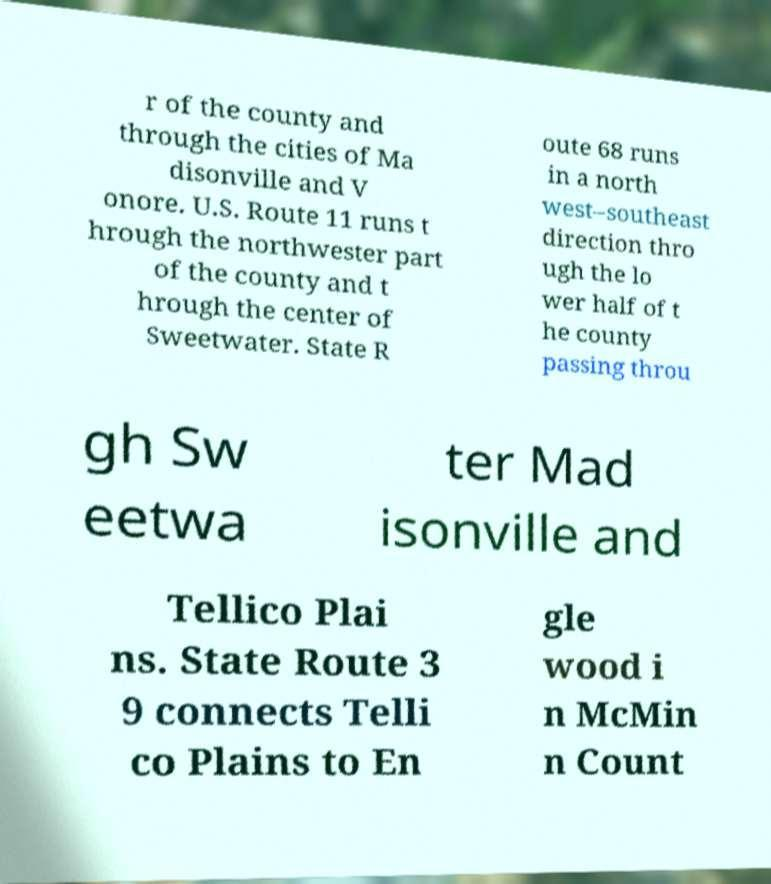Can you accurately transcribe the text from the provided image for me? r of the county and through the cities of Ma disonville and V onore. U.S. Route 11 runs t hrough the northwester part of the county and t hrough the center of Sweetwater. State R oute 68 runs in a north west–southeast direction thro ugh the lo wer half of t he county passing throu gh Sw eetwa ter Mad isonville and Tellico Plai ns. State Route 3 9 connects Telli co Plains to En gle wood i n McMin n Count 